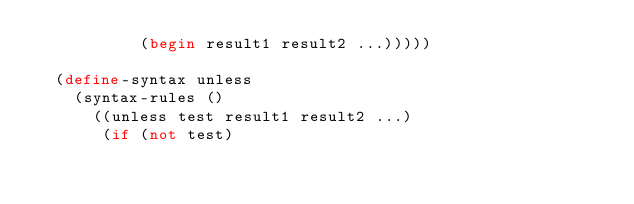Convert code to text. <code><loc_0><loc_0><loc_500><loc_500><_Scheme_>           (begin result1 result2 ...)))))

  (define-syntax unless
    (syntax-rules ()
      ((unless test result1 result2 ...)
       (if (not test)</code> 